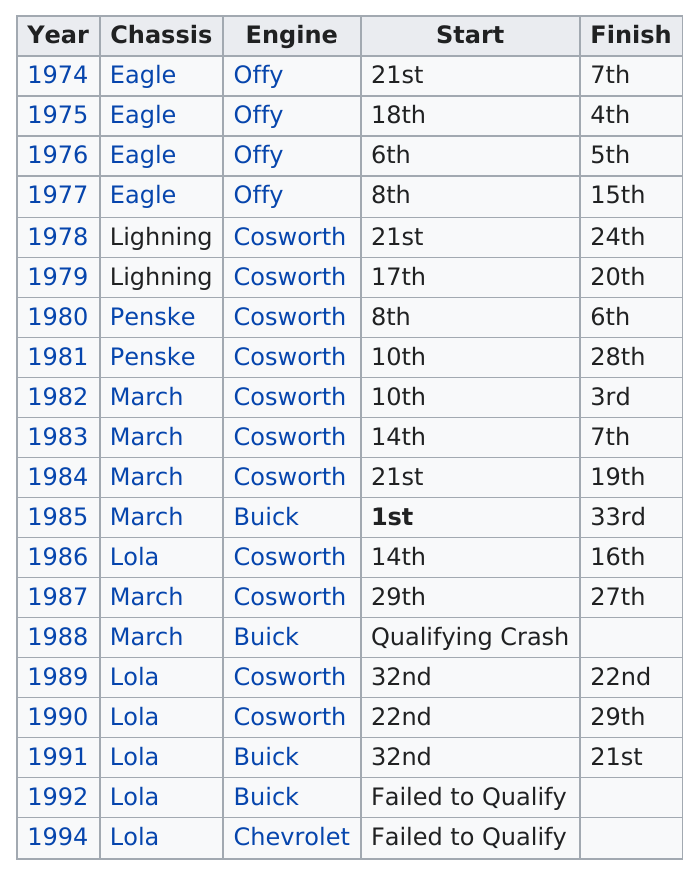Specify some key components in this picture. Nine engines were not Cosworths. Six chassis were built by Lola. The average engine type listed on the website is Cosworth. The finish was 7th in how many years? Two years. Pancho Carter used four Offy engines in his Indy 500 race car. 